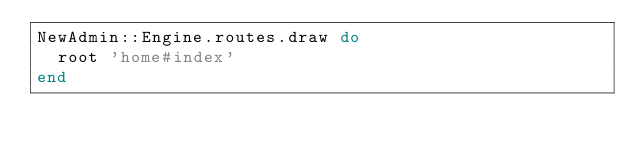<code> <loc_0><loc_0><loc_500><loc_500><_Ruby_>NewAdmin::Engine.routes.draw do
  root 'home#index'
end
</code> 